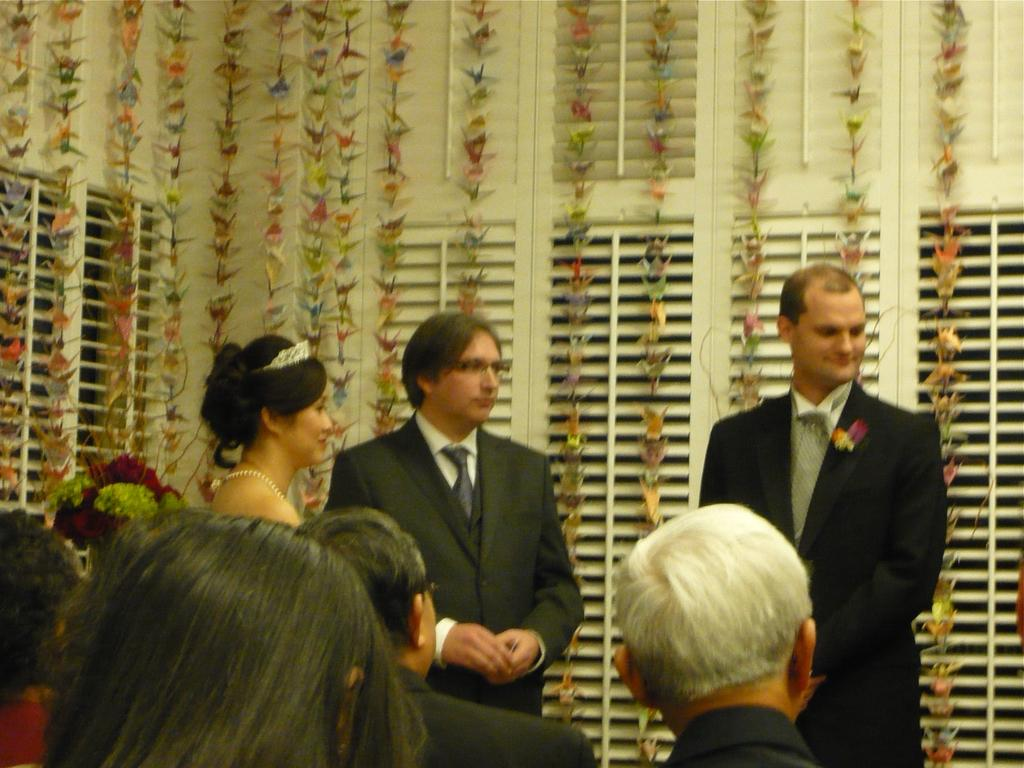What is present in the image? There are people in the image. What object can be seen in addition to the people? There is a flower vase in the image. What can be seen in the background of the image? There are ribbons and windows in the background of the image. What type of calculator is being used by the people in the image? There is no calculator present in the image. How many cannons are visible in the image? There are no cannons present in the image. What type of chair is being used by the people in the image? There is no chair present in the image. 